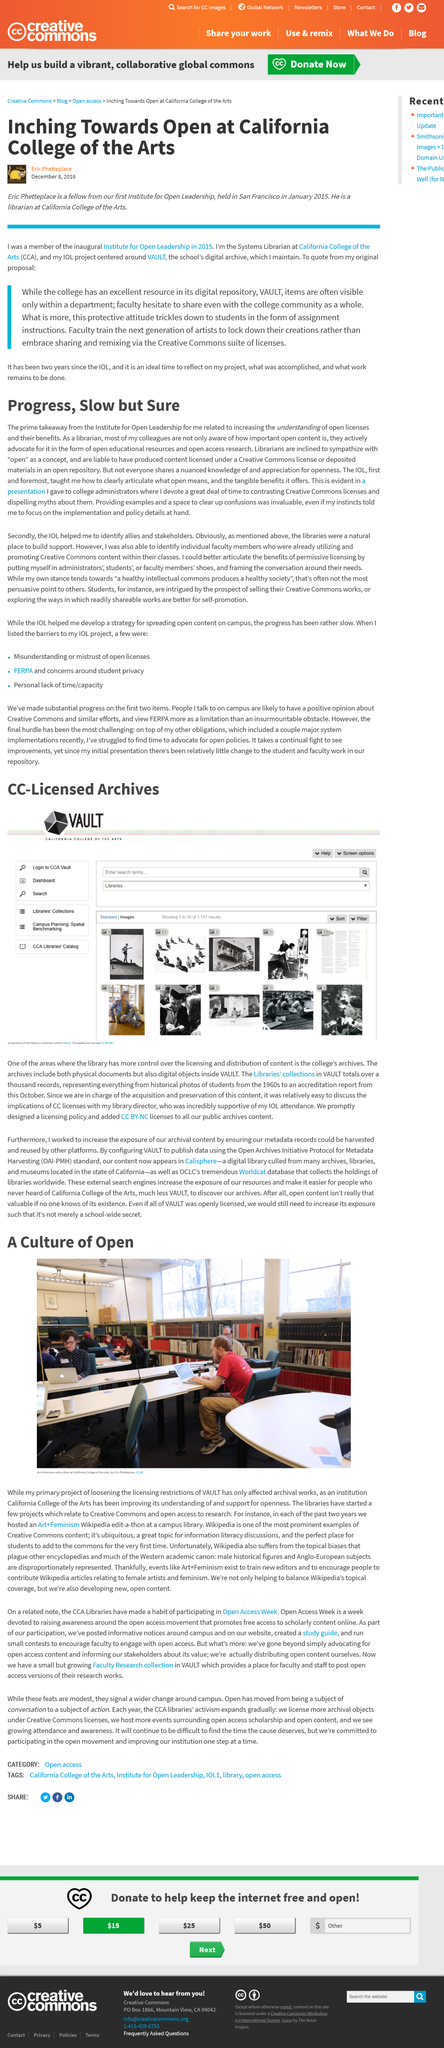Give some essential details in this illustration. An Art + Feminism Wikipedia edit-a-thon was hosted to celebrate International Women's Day 2023. California College of the Arts is mentioned in this article. The photograph was taken at the California College of the Arts. Librarians are inclined to sympathize with the concept of "open" as it pertains to copyright-free knowledge. The author believes that making VAULT content accessible to more users would encourage the next generation of artists to embrace Creative Commons licensing for sharing and remixing their works. 